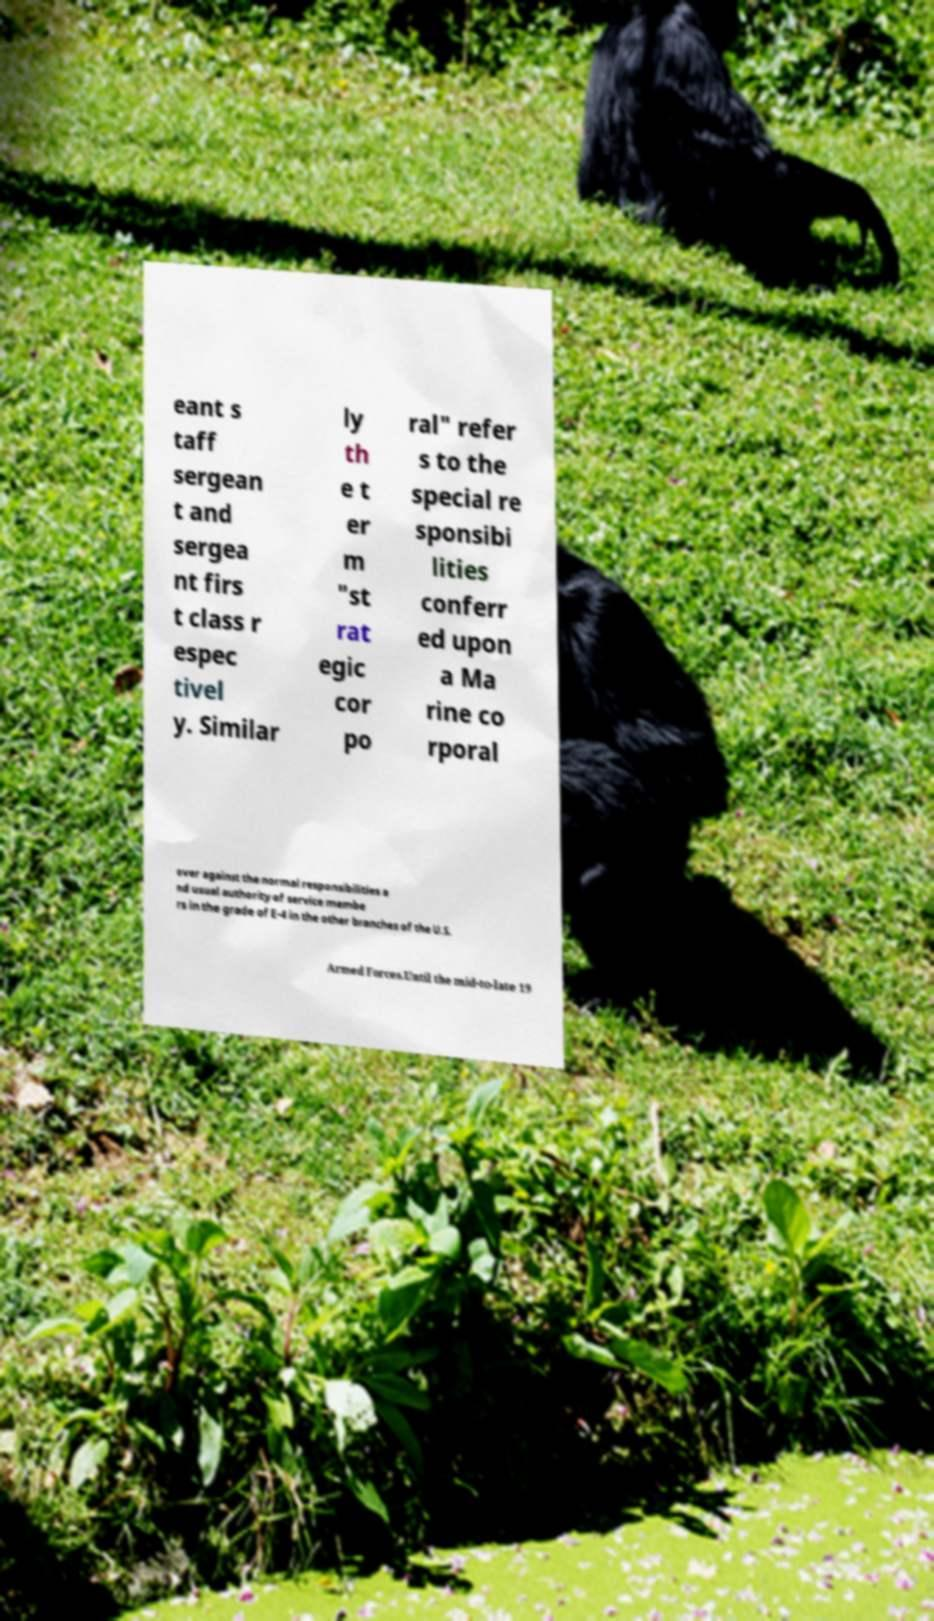Could you assist in decoding the text presented in this image and type it out clearly? eant s taff sergean t and sergea nt firs t class r espec tivel y. Similar ly th e t er m "st rat egic cor po ral" refer s to the special re sponsibi lities conferr ed upon a Ma rine co rporal over against the normal responsibilities a nd usual authority of service membe rs in the grade of E-4 in the other branches of the U.S. Armed Forces.Until the mid-to-late 19 